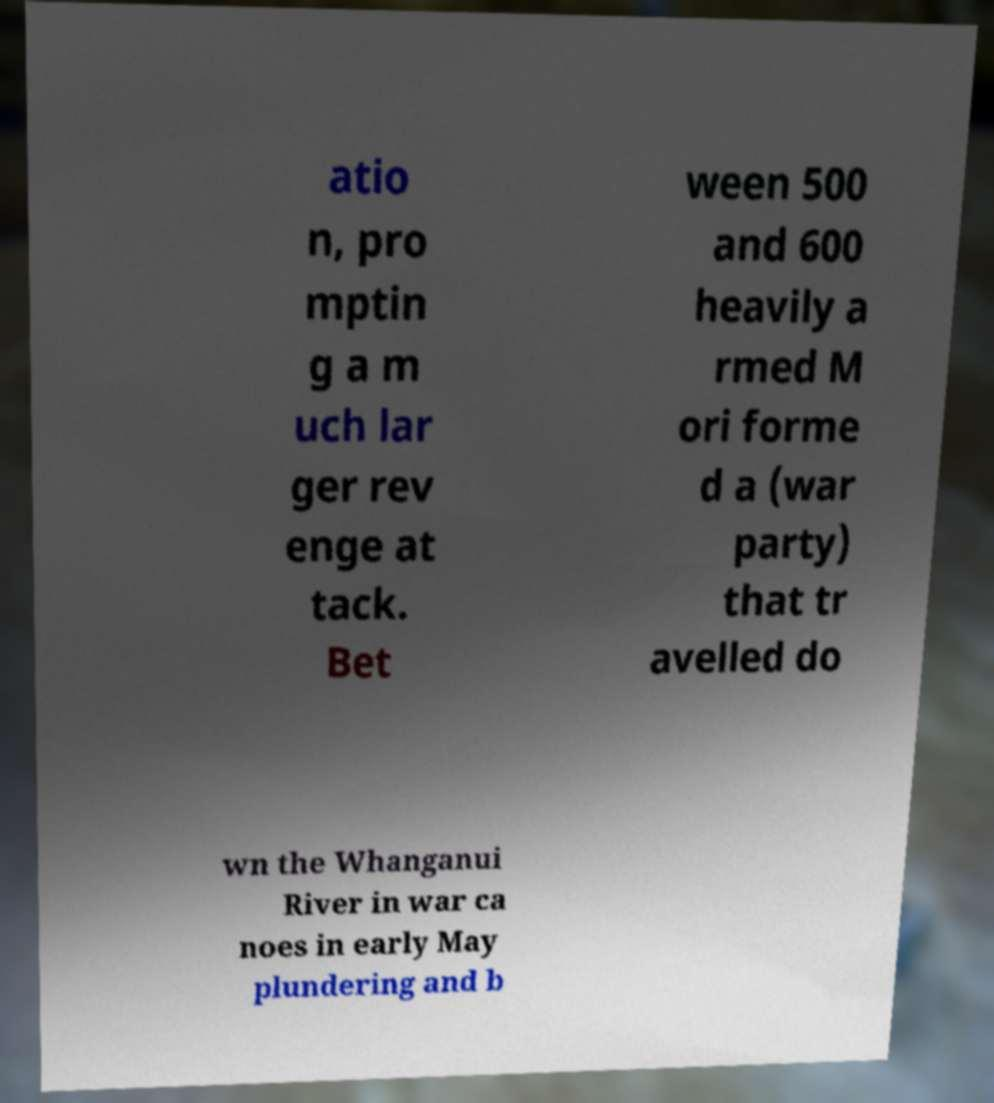I need the written content from this picture converted into text. Can you do that? atio n, pro mptin g a m uch lar ger rev enge at tack. Bet ween 500 and 600 heavily a rmed M ori forme d a (war party) that tr avelled do wn the Whanganui River in war ca noes in early May plundering and b 